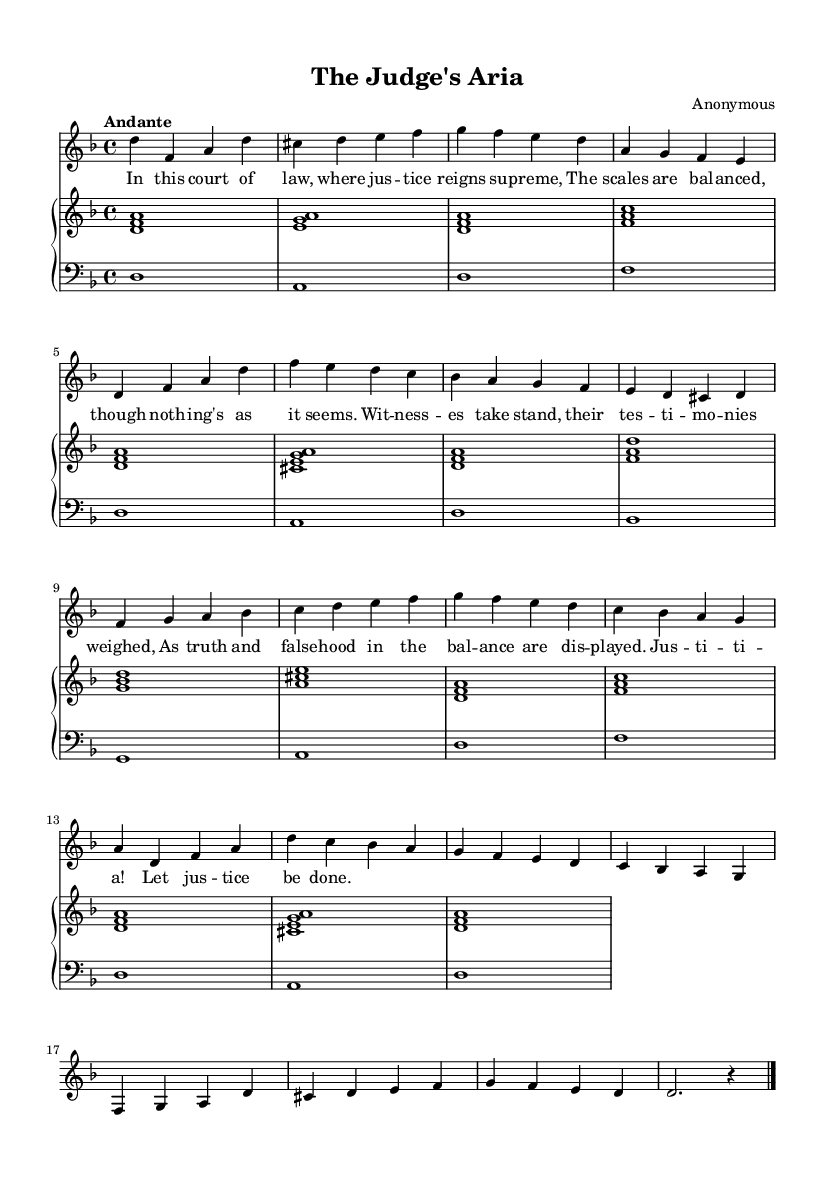What is the key signature of this music? The key signature indicated in the score is D minor, which has one flat (B flat). This can be seen at the beginning of the staff where the flats are placed.
Answer: D minor What is the time signature of this piece? The time signature located at the beginning of the score is 4/4, which means there are four beats in each measure and the quarter note gets the beat.
Answer: 4/4 What tempo is indicated for this piece? The tempo marking in the score is “Andante,” which suggests a moderate walking pace, typically around 76 to 108 beats per minute.
Answer: Andante How many verses are included in the piece? The score shows two distinct verses, each outlined in the lyrics section, corresponding to the indicated musical phrases.
Answer: Two What is the emotional theme of the lyrics? The lyrics revolve around themes of justice, truth, and courtroom dynamics, particularly expressing the seriousness and complexity of legal proceedings. This connection can be deduced from the content of the lyrics.
Answer: Justice What is the structure of the piece? The structure consists of an introduction, two verses, a melismatic section, and a coda, showcasing a typical arrangement in Baroque opera where narratives unfold through distinct musical sections.
Answer: Introduction, Verse 1, Verse 2, Melismatic section, Coda What distinctive feature of Baroque music is present in the melismatic section? The melismatic section allows for expressive vocal embellishment, which is a characteristic trait of Baroque opera. This is evident in the extended notes and expressive phrasing typical of the era.
Answer: Melisma 